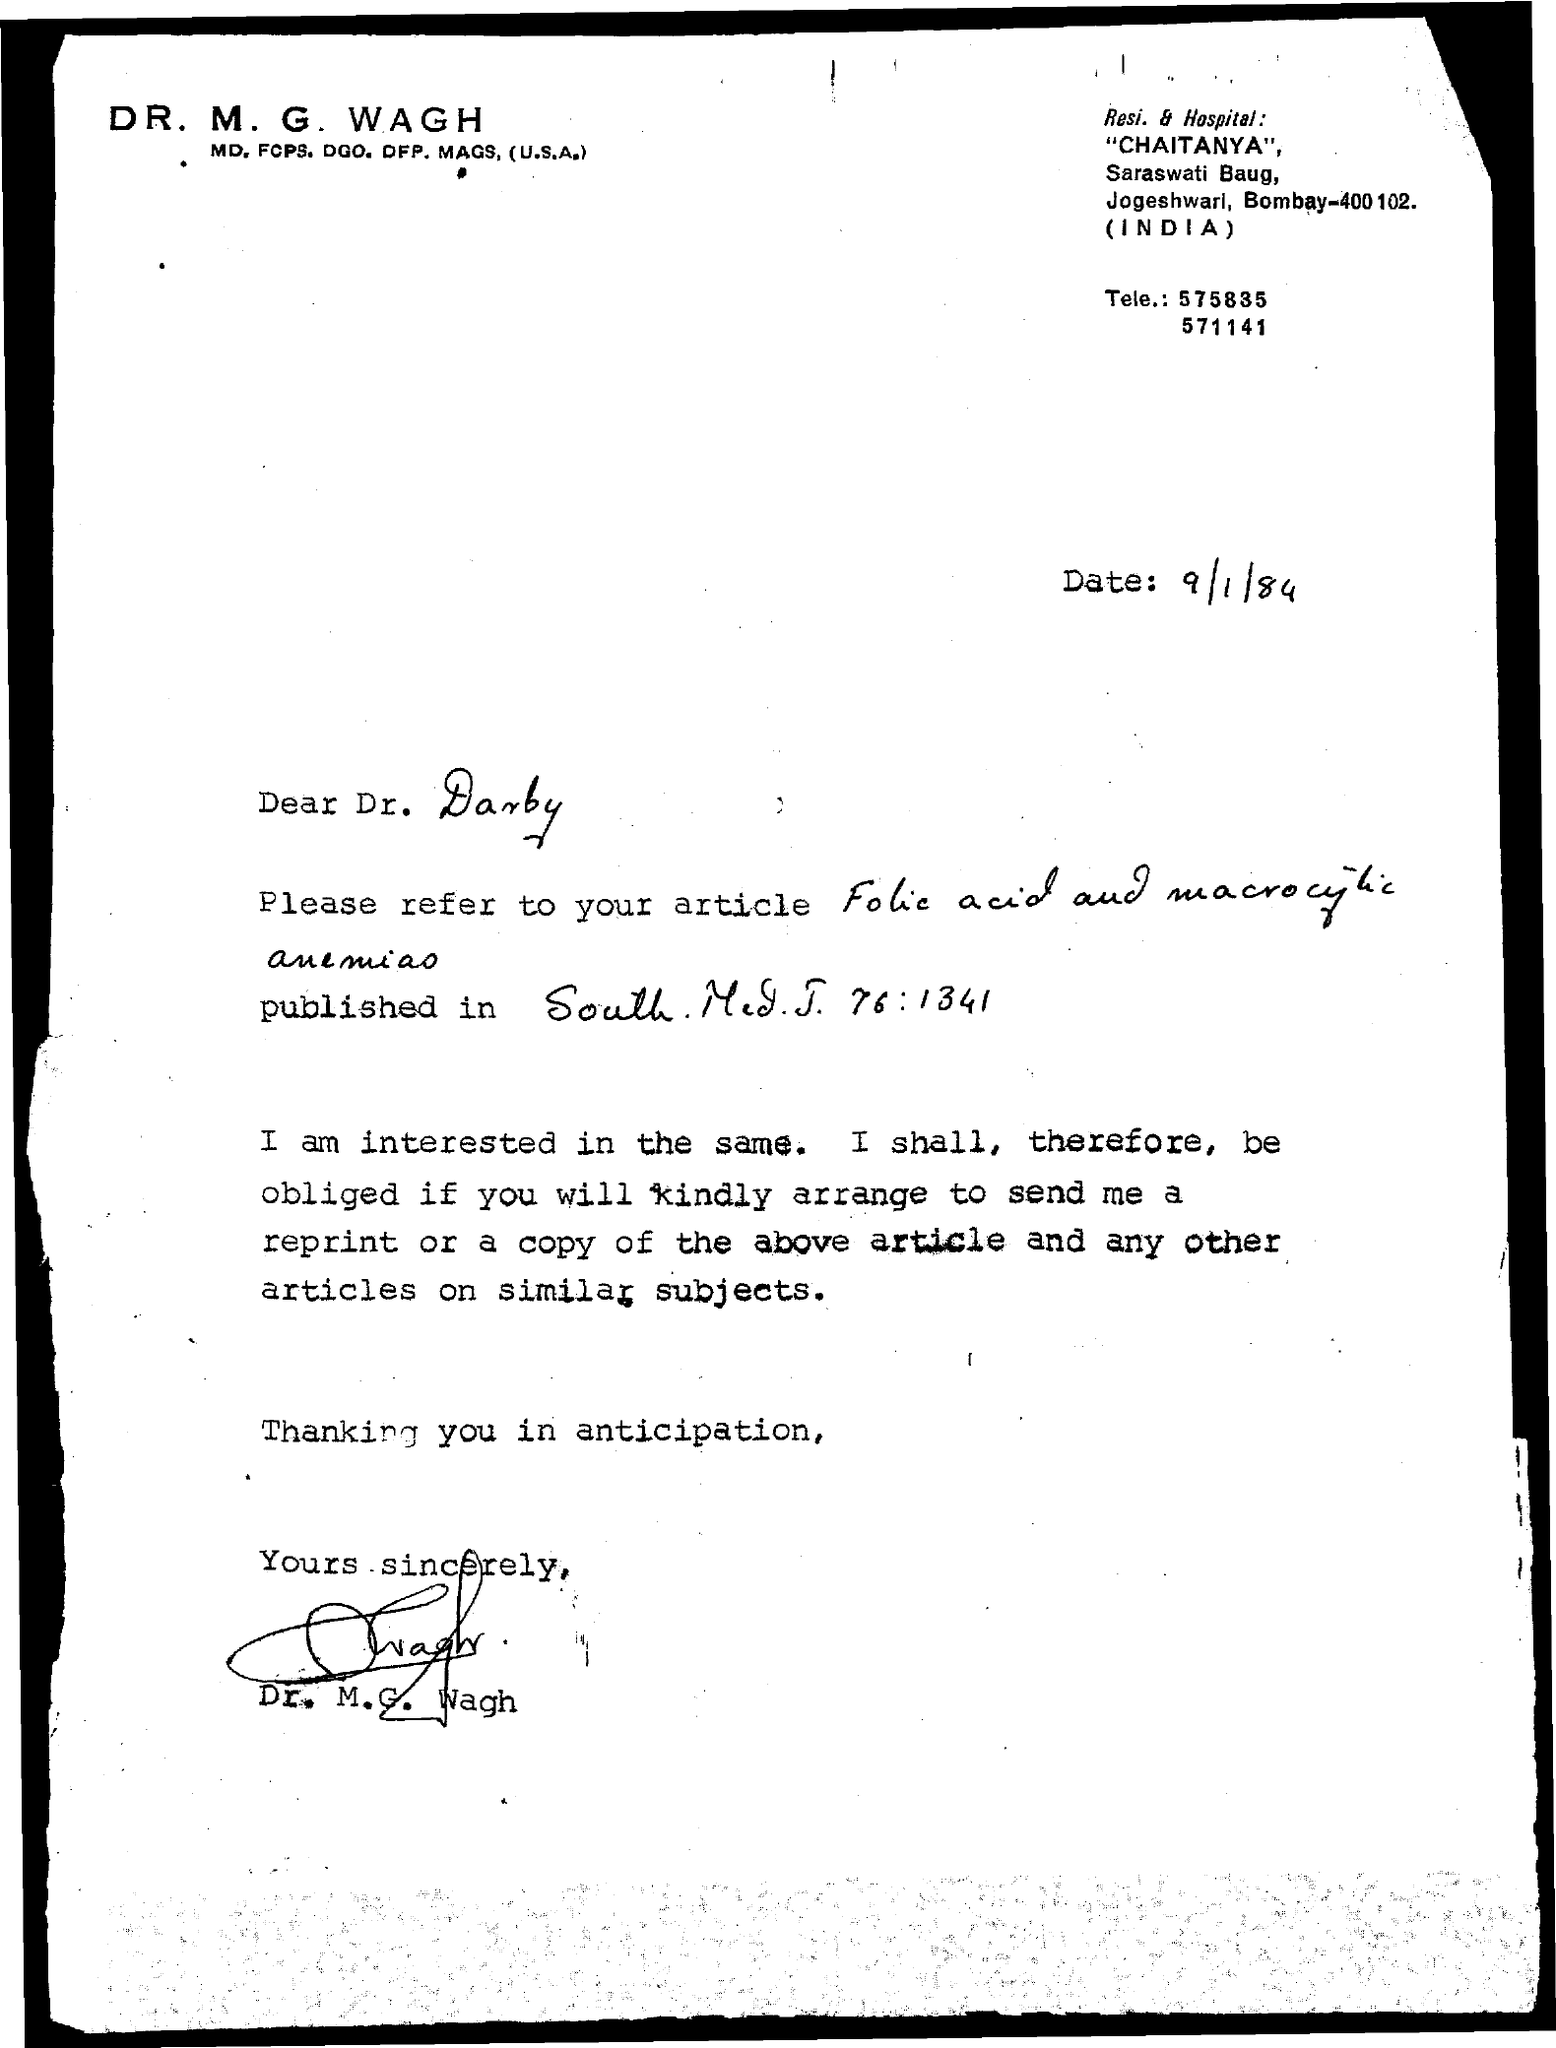What is the date mentioned in the given letter ?
Your answer should be very brief. 9/1/84. Who has signed at the bottom of the letter ?
Provide a succinct answer. Dr. M.G. Wagh. 